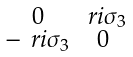<formula> <loc_0><loc_0><loc_500><loc_500>\begin{smallmatrix} 0 & \ r i \sigma _ { 3 } \\ - \ r i \sigma _ { 3 } & 0 \end{smallmatrix}</formula> 